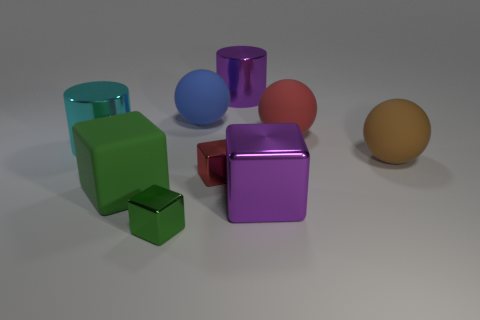The cyan thing that is the same size as the red sphere is what shape?
Your answer should be very brief. Cylinder. There is a block that is both in front of the tiny red shiny block and right of the blue matte ball; what material is it?
Offer a very short reply. Metal. Are there fewer tiny red shiny things than small blue cylinders?
Offer a very short reply. No. There is a large purple thing behind the big shiny cylinder on the left side of the big purple metallic cylinder; is there a cyan thing that is behind it?
Provide a succinct answer. No. Is the shape of the big purple thing on the left side of the large purple block the same as  the large blue thing?
Your response must be concise. No. Are there more small shiny things on the right side of the large red matte thing than small blocks?
Give a very brief answer. No. There is a tiny metal thing that is behind the big green thing; is its color the same as the matte cube?
Offer a very short reply. No. Is there any other thing that has the same color as the large matte cube?
Give a very brief answer. Yes. What is the color of the large shiny object that is to the right of the shiny thing that is behind the metallic cylinder in front of the blue matte thing?
Ensure brevity in your answer.  Purple. Does the red metal thing have the same size as the brown sphere?
Give a very brief answer. No. 